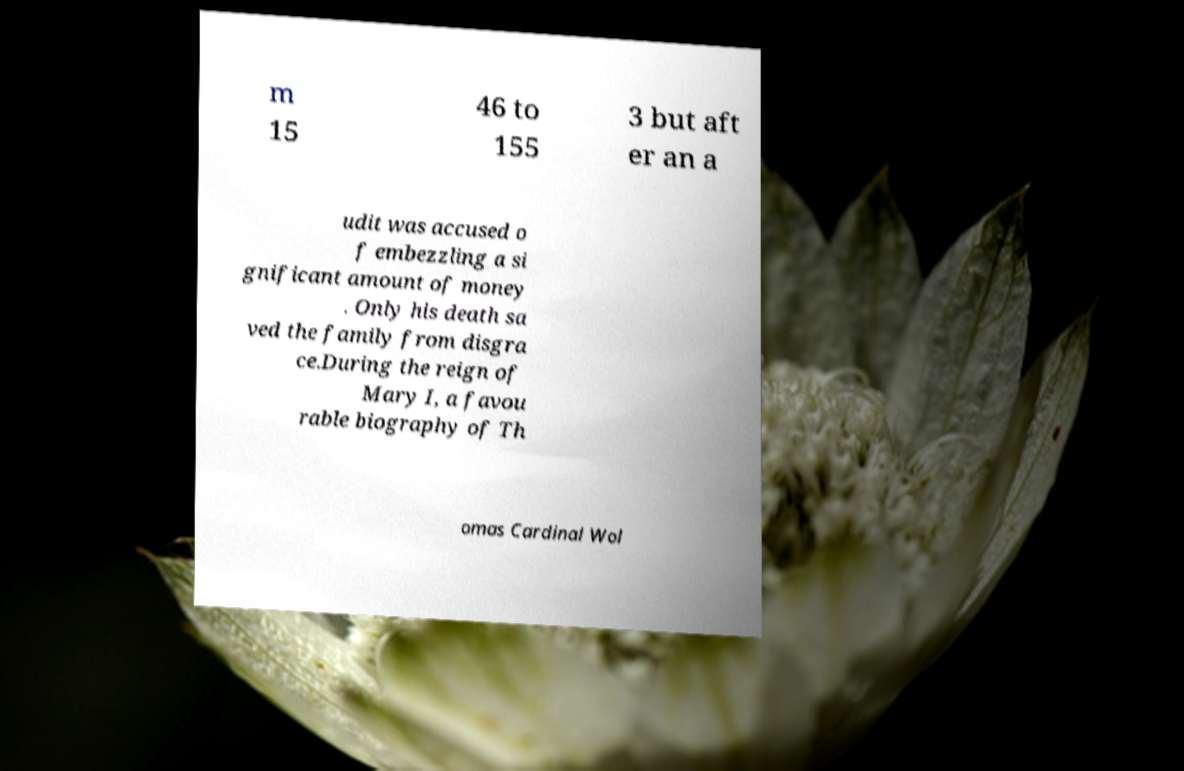Can you read and provide the text displayed in the image?This photo seems to have some interesting text. Can you extract and type it out for me? m 15 46 to 155 3 but aft er an a udit was accused o f embezzling a si gnificant amount of money . Only his death sa ved the family from disgra ce.During the reign of Mary I, a favou rable biography of Th omas Cardinal Wol 